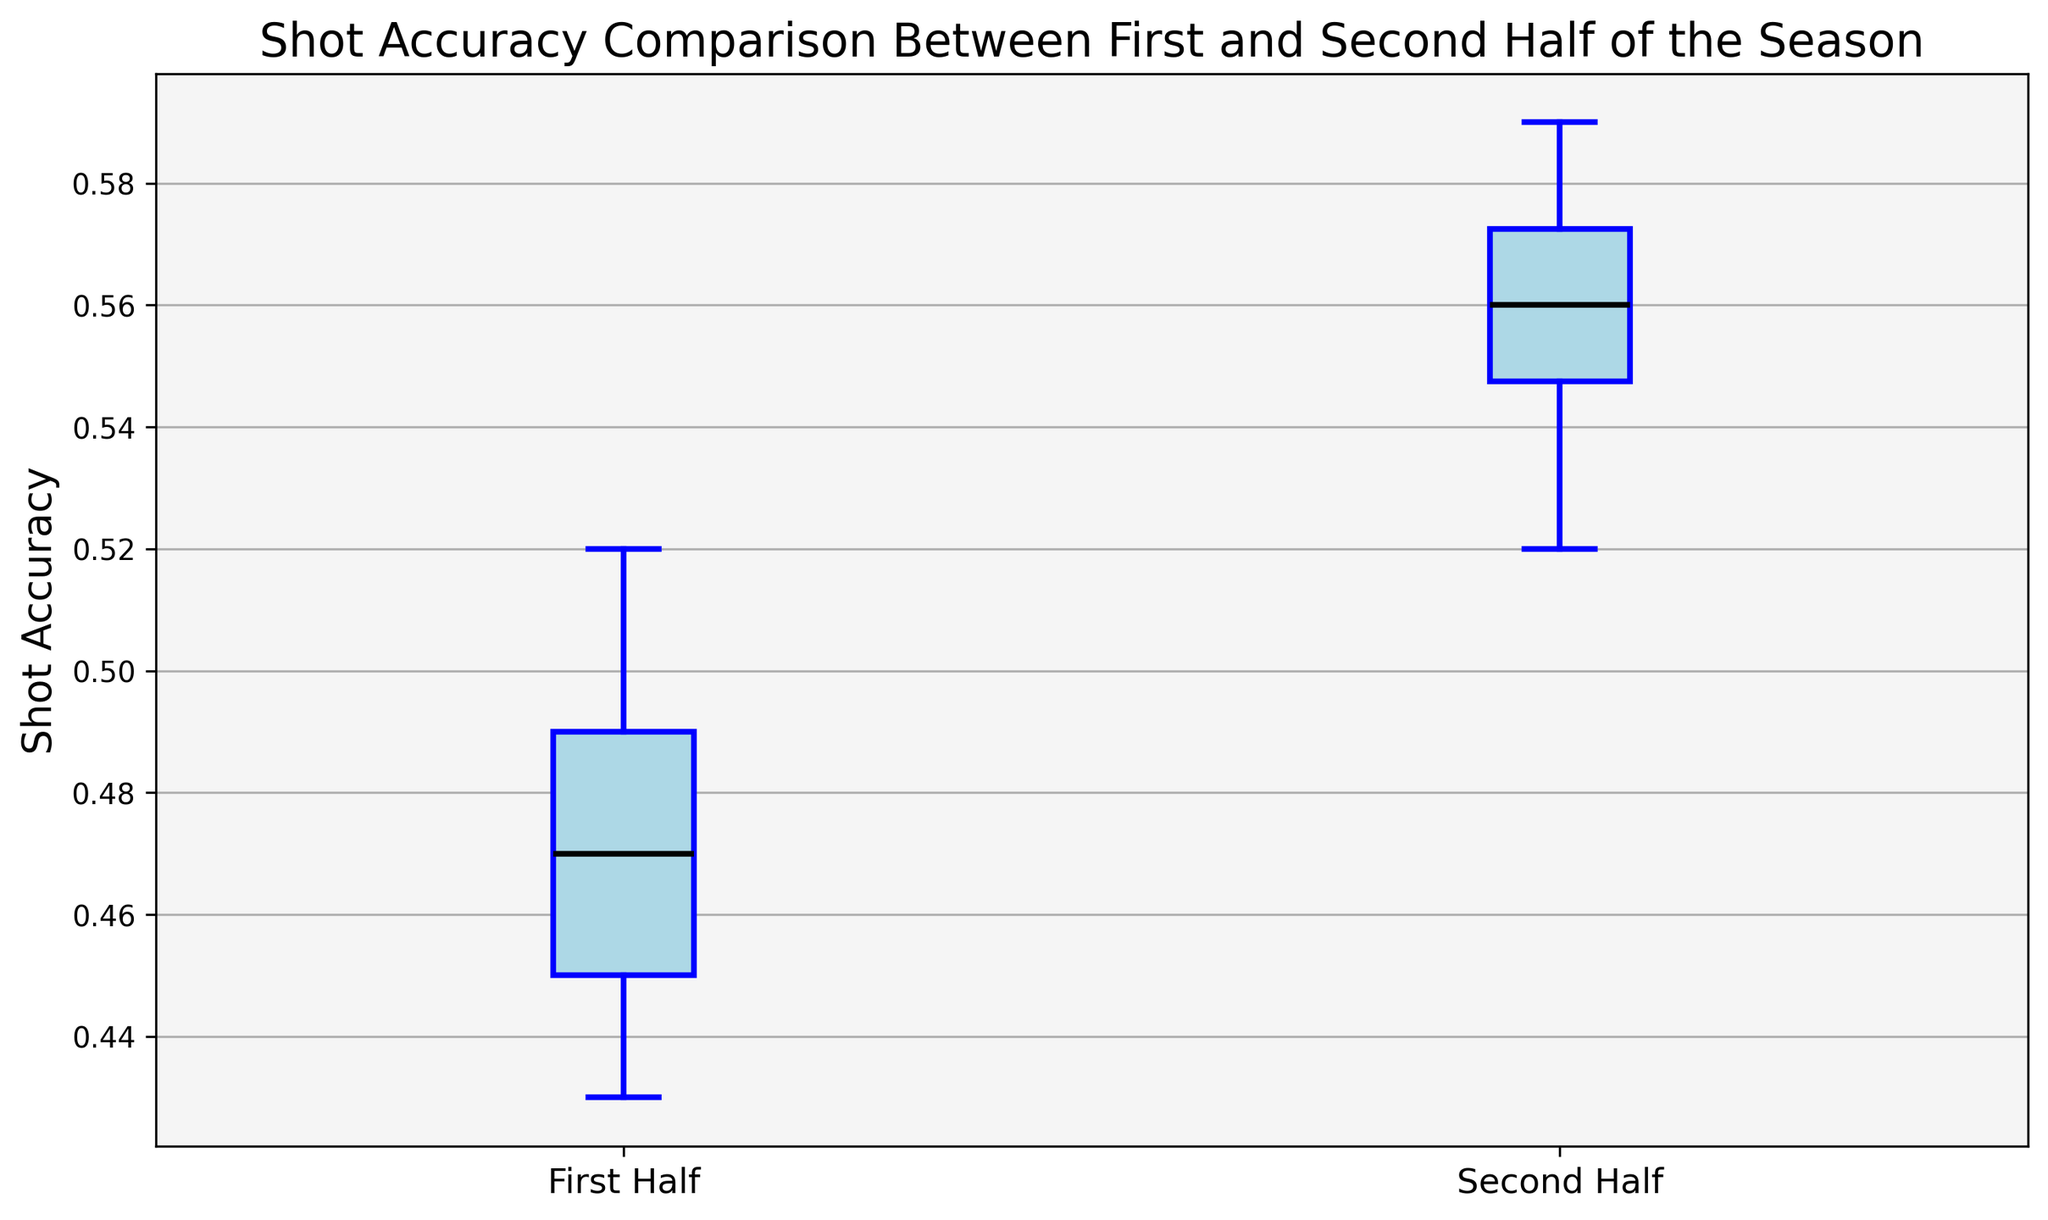Which period has the higher median shot accuracy? To determine this, look at the line inside the boxes. The median shot accuracy for the first half appears to be lower than that of the second half.
Answer: Second Half What is the interquartile range (IQR) for the shot accuracy in the first half? The IQR is calculated as the difference between the third quartile (Q3) and the first quartile (Q1) values. From the plot, estimate the approximate Q3 and Q1 and find their difference.
Answer: About 0.05 How does the spread of shot accuracy in the first half compare to the second half? Evaluate the length of the boxes to determine the spread. The first half box appears shorter, indicating less variability compared to the second half.
Answer: Less variability in the First Half Which period shows a higher maximum shot accuracy? The maximum values are represented by the upper whisker of each box. The second half’s whisker extends higher than the first half’s whisker.
Answer: Second Half Are there any outliers in shot accuracy in either period? Outliers are represented as individual points outside the whiskers. The figure does not show any individual outlier points.
Answer: No Which period exhibits a higher lower quartile (Q1) value for shot accuracy? Look at the bottom edges of the boxes. The second-half period's Q1 edge is higher up than the first half's Q1 edge.
Answer: Second Half What is the difference in median shot accuracy between the first and second half? The median of the first half is around 0.47, and the second half is about 0.56. Subtract to find the difference, 0.56 - 0.47.
Answer: 0.09 Which period has a wider interquartile range (IQR)? The wider box indicates a greater IQR. Visually assess which box is longer.
Answer: Second Half How does the median accuracy of the first half compare to the lower quartile of the second half? The first-half median is around 0.47, and the second-half Q1 is also around 0.54. The second half’s lower quartile is higher than the first half’s median.
Answer: Second Half’s Q1 higher 